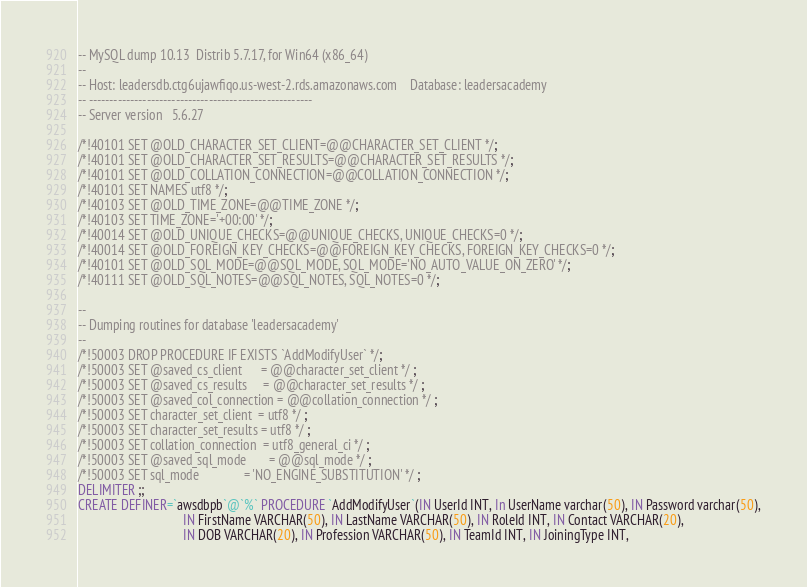Convert code to text. <code><loc_0><loc_0><loc_500><loc_500><_SQL_>-- MySQL dump 10.13  Distrib 5.7.17, for Win64 (x86_64)
--
-- Host: leadersdb.ctg6ujawfiqo.us-west-2.rds.amazonaws.com    Database: leadersacademy
-- ------------------------------------------------------
-- Server version	5.6.27

/*!40101 SET @OLD_CHARACTER_SET_CLIENT=@@CHARACTER_SET_CLIENT */;
/*!40101 SET @OLD_CHARACTER_SET_RESULTS=@@CHARACTER_SET_RESULTS */;
/*!40101 SET @OLD_COLLATION_CONNECTION=@@COLLATION_CONNECTION */;
/*!40101 SET NAMES utf8 */;
/*!40103 SET @OLD_TIME_ZONE=@@TIME_ZONE */;
/*!40103 SET TIME_ZONE='+00:00' */;
/*!40014 SET @OLD_UNIQUE_CHECKS=@@UNIQUE_CHECKS, UNIQUE_CHECKS=0 */;
/*!40014 SET @OLD_FOREIGN_KEY_CHECKS=@@FOREIGN_KEY_CHECKS, FOREIGN_KEY_CHECKS=0 */;
/*!40101 SET @OLD_SQL_MODE=@@SQL_MODE, SQL_MODE='NO_AUTO_VALUE_ON_ZERO' */;
/*!40111 SET @OLD_SQL_NOTES=@@SQL_NOTES, SQL_NOTES=0 */;

--
-- Dumping routines for database 'leadersacademy'
--
/*!50003 DROP PROCEDURE IF EXISTS `AddModifyUser` */;
/*!50003 SET @saved_cs_client      = @@character_set_client */ ;
/*!50003 SET @saved_cs_results     = @@character_set_results */ ;
/*!50003 SET @saved_col_connection = @@collation_connection */ ;
/*!50003 SET character_set_client  = utf8 */ ;
/*!50003 SET character_set_results = utf8 */ ;
/*!50003 SET collation_connection  = utf8_general_ci */ ;
/*!50003 SET @saved_sql_mode       = @@sql_mode */ ;
/*!50003 SET sql_mode              = 'NO_ENGINE_SUBSTITUTION' */ ;
DELIMITER ;;
CREATE DEFINER=`awsdbpb`@`%` PROCEDURE `AddModifyUser`(IN UserId INT, In UserName varchar(50), IN Password varchar(50),
								 IN FirstName VARCHAR(50), IN LastName VARCHAR(50), IN RoleId INT, IN Contact VARCHAR(20),
                                 IN DOB VARCHAR(20), IN Profession VARCHAR(50), IN TeamId INT, IN JoiningType INT, </code> 